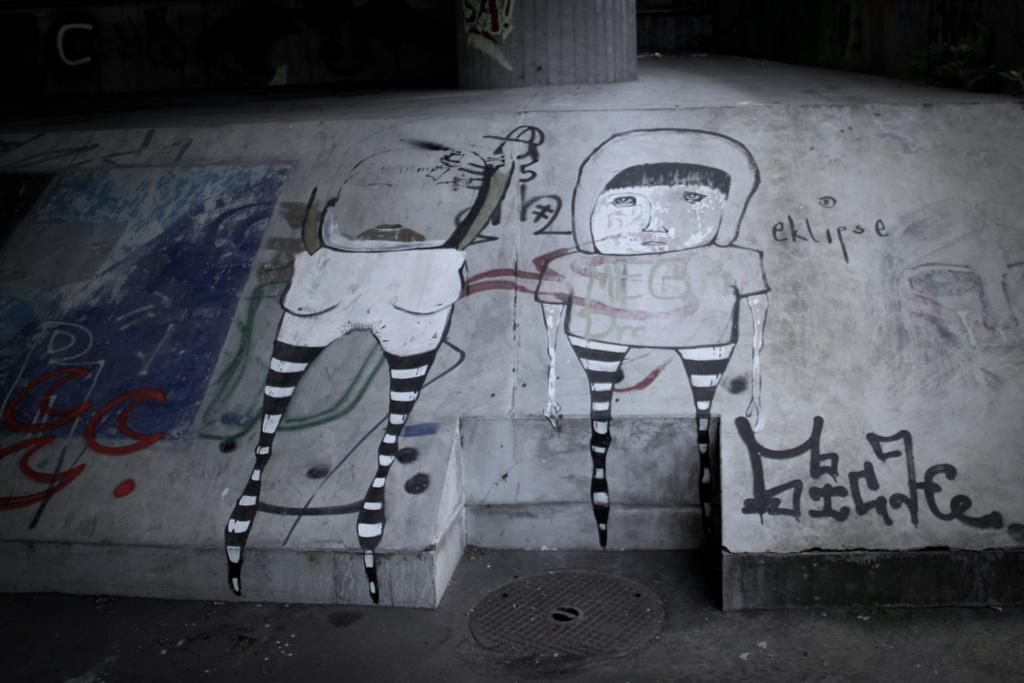What is hanging on the wall in the image? There is a painting on the wall in the image. What else can be seen in the image besides the painting in the image? There is text visible in the image. Is there any blood visible on the painting in the image? No, there is no blood visible on the painting in the image. What type of crayon is being used to write the text in the image? There is no crayon present in the image; the text is not written with a crayon. 